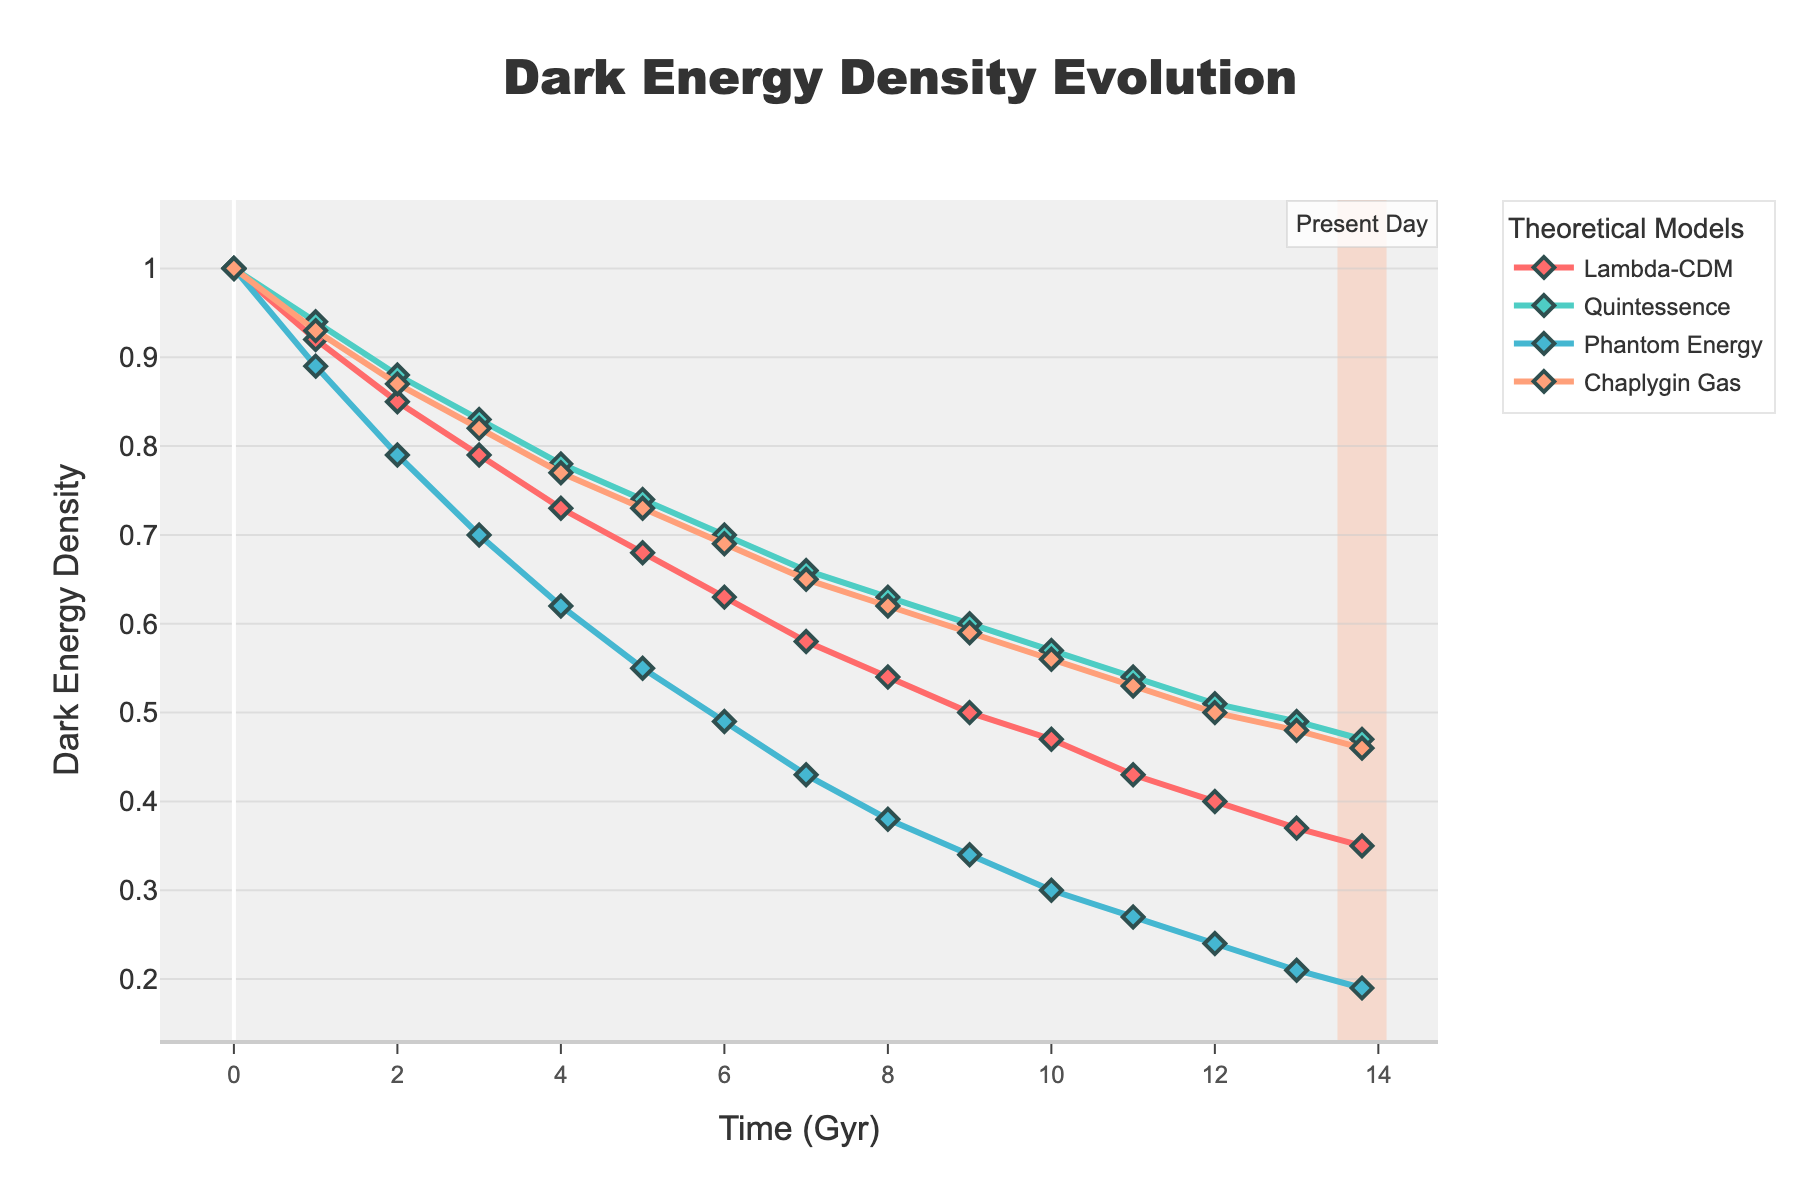How does the dark energy density evolve according to the Lambda-CDM model from the beginning of cosmic history to the present day? By observing the blue line in the plot, we can see that the dark energy density decreases from 1.0 at 0 Gyr to approximately 0.35 at 13.8 Gyr.
Answer: It decreases from 1.0 to 0.35 Which theoretical model shows the steepest decline in dark energy density over time? The Phantom Energy model, represented by the red line, shows the steepest decline from 1.0 at 0 Gyr to approximately 0.19 at 13.8 Gyr, which is a more significant decrease compared to other models.
Answer: Phantom Energy At the present day, which model predicts the highest dark energy density? At 13.8 Gyr, the Lambda-CDM model shows the highest dark energy density, approximately 0.35, as indicated by the plot.
Answer: Lambda-CDM What is the range of dark energy density values predicted by the Chaplygin Gas model over the given timespan? The Chaplygin Gas model (purple line) starts at 1.0 at 0 Gyr and decreases to approximately 0.46 at 13.8 Gyr. So, the range is from 1.0 to 0.46.
Answer: 1.0 to 0.46 Compare the dark energy density at 5 Gyr for all models. Which one has the highest density and which one has the lowest? At 5 Gyr, the Lambda-CDM model has a density of 0.68, Quintessence has 0.74, Phantom Energy has 0.55, and Chaplygin Gas has 0.73. The highest value is for Quintessence (0.74), and the lowest is for Phantom Energy (0.55).
Answer: Highest: Quintessence, Lowest: Phantom Energy By how much does the dark energy density decrease in the Quintessence model from 1 Gyr to 10 Gyr? At 1 Gyr, the density is 0.94, and at 10 Gyr, it is 0.57. The decrease is calculated as 0.94 - 0.57 = 0.37.
Answer: 0.37 What can be inferred about the rate of decline in dark energy density for the Lambda-CDM and Chaplygin Gas models between 0 and 5 Gyr? In the first 5 Gyr, the Lambda-CDM model's density falls from 1.0 to 0.68 (a decrease of 0.32), while the Chaplygin Gas model's density falls from 1.0 to 0.73 (a decrease of 0.27). The Lambda-CDM model has a steeper initial decline compared to Chaplygin Gas.
Answer: Lambda-CDM has a steeper decline Which theoretical model maintains a relatively steady rate of decline in dark energy density throughout the observed period? The Quintessence model (green line) shows a relatively steady rate of decline from 1.0 at 0 Gyr to approximately 0.47 at 13.8 Gyr, unlike other models with more variable rates.
Answer: Quintessence If dark energy density at 8 Gyr were the average of densities at 3 Gyr and 13.8 Gyr in the Phantom Energy model, what would be the expected value? The average of densities at 3 Gyr (0.70) and 13.8 Gyr (0.19) is (0.70 + 0.19) / 2 = 0.445. The observed value at 8 Gyr is 0.38, which is lower than the expected average.
Answer: 0.445 